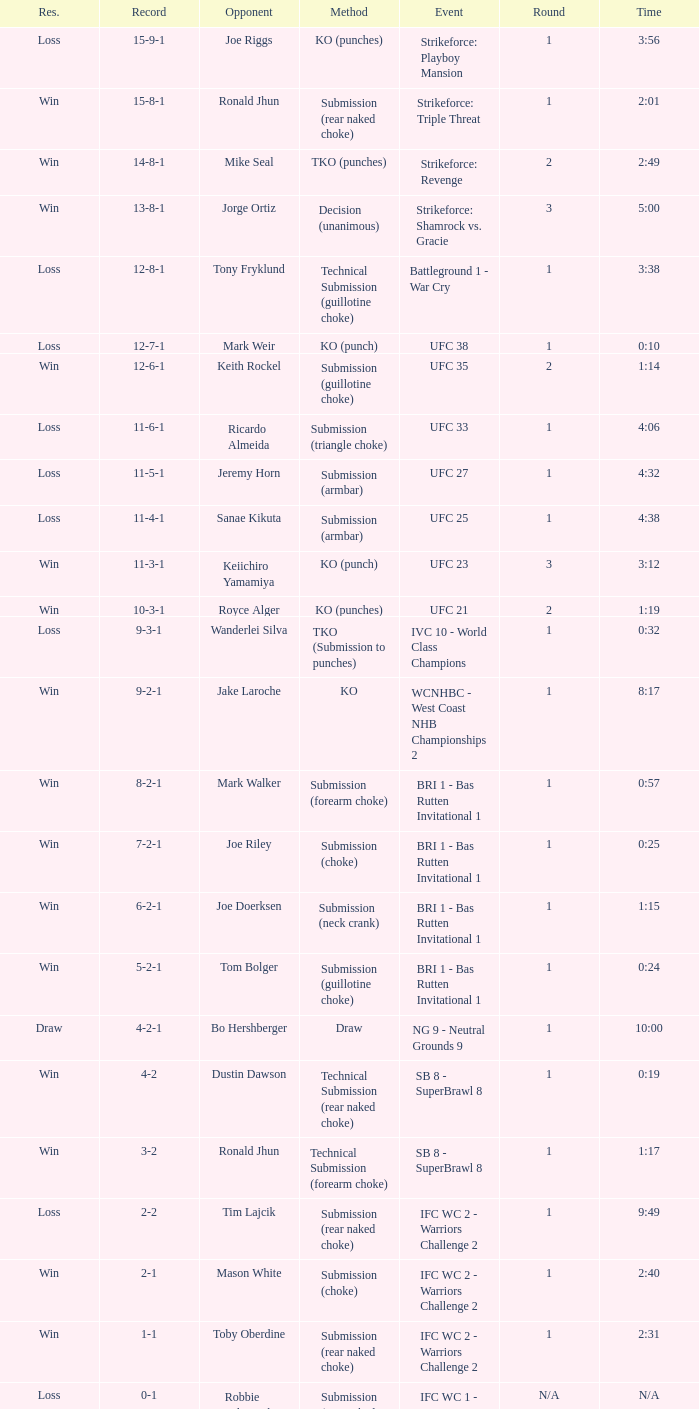What is the record when the fight was against keith rockel? 12-6-1. 